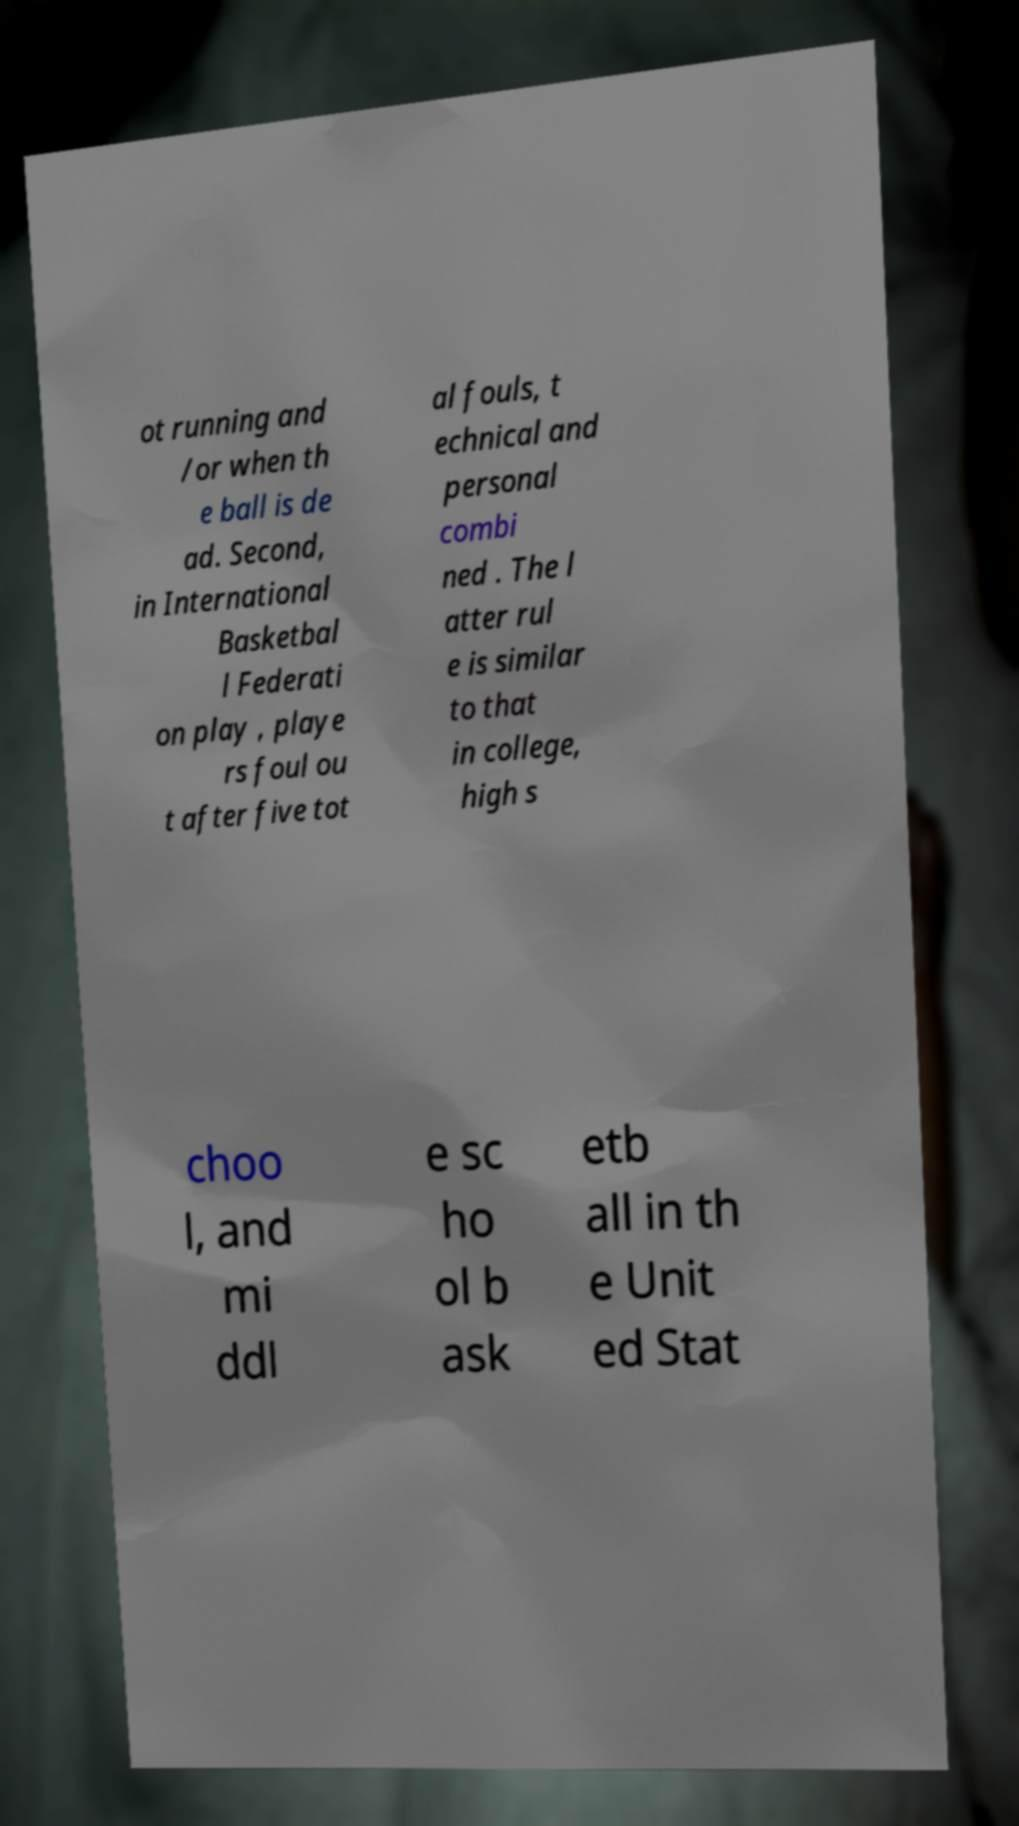Can you read and provide the text displayed in the image?This photo seems to have some interesting text. Can you extract and type it out for me? ot running and /or when th e ball is de ad. Second, in International Basketbal l Federati on play , playe rs foul ou t after five tot al fouls, t echnical and personal combi ned . The l atter rul e is similar to that in college, high s choo l, and mi ddl e sc ho ol b ask etb all in th e Unit ed Stat 